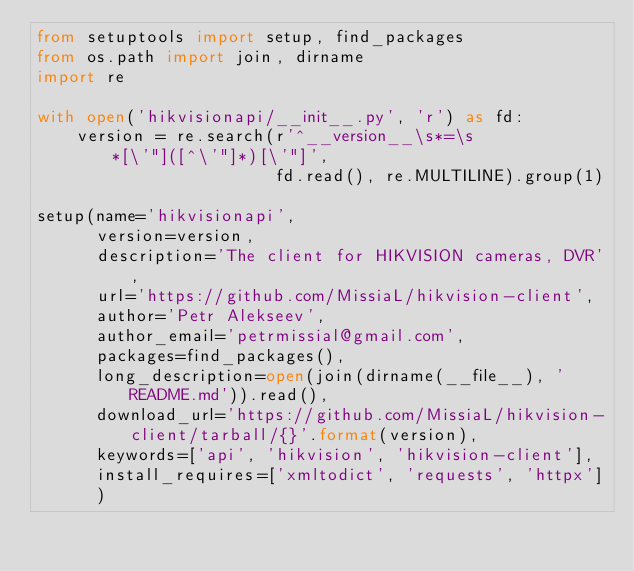Convert code to text. <code><loc_0><loc_0><loc_500><loc_500><_Python_>from setuptools import setup, find_packages
from os.path import join, dirname
import re

with open('hikvisionapi/__init__.py', 'r') as fd:
    version = re.search(r'^__version__\s*=\s*[\'"]([^\'"]*)[\'"]',
                        fd.read(), re.MULTILINE).group(1)

setup(name='hikvisionapi',
      version=version,
      description='The client for HIKVISION cameras, DVR',
      url='https://github.com/MissiaL/hikvision-client',
      author='Petr Alekseev',
      author_email='petrmissial@gmail.com',
      packages=find_packages(),
      long_description=open(join(dirname(__file__), 'README.md')).read(),
      download_url='https://github.com/MissiaL/hikvision-client/tarball/{}'.format(version),
      keywords=['api', 'hikvision', 'hikvision-client'],
      install_requires=['xmltodict', 'requests', 'httpx']
      )
</code> 